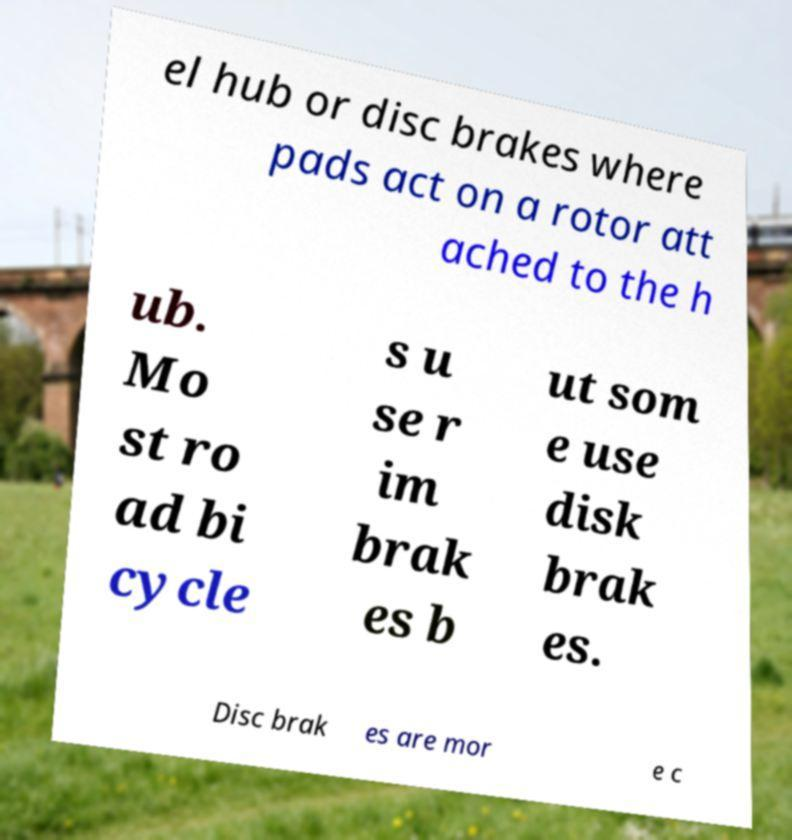For documentation purposes, I need the text within this image transcribed. Could you provide that? el hub or disc brakes where pads act on a rotor att ached to the h ub. Mo st ro ad bi cycle s u se r im brak es b ut som e use disk brak es. Disc brak es are mor e c 